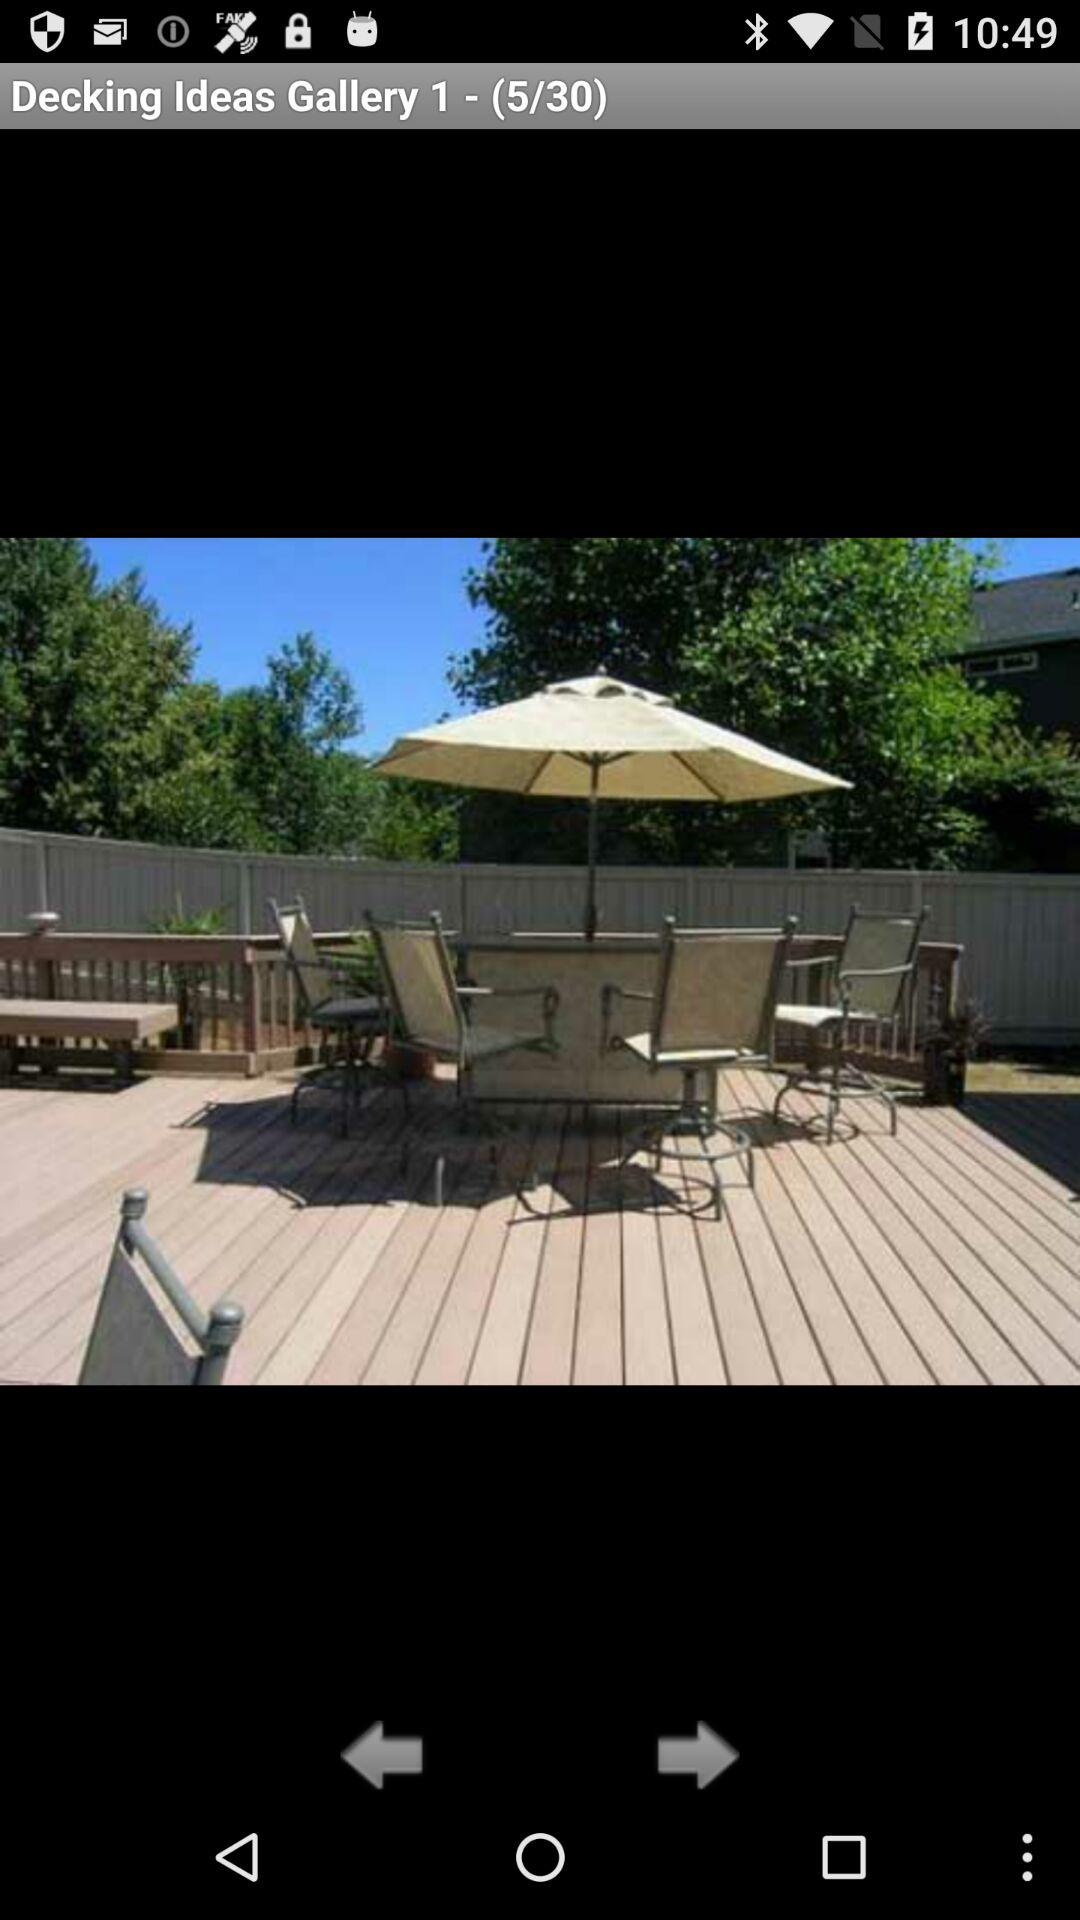How many pictures in total are there in the gallery? There are 30 pictures in the gallery. 